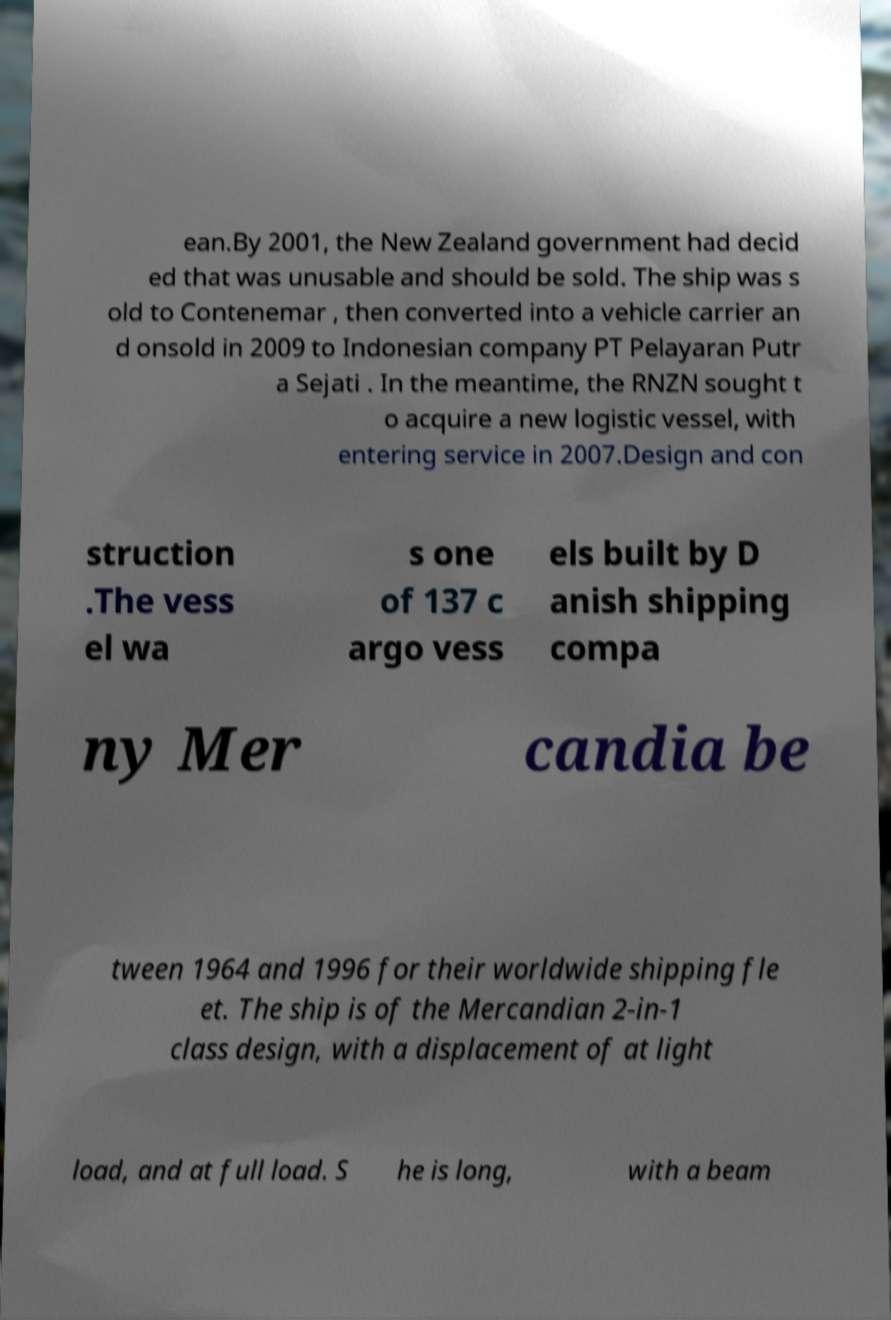Please identify and transcribe the text found in this image. ean.By 2001, the New Zealand government had decid ed that was unusable and should be sold. The ship was s old to Contenemar , then converted into a vehicle carrier an d onsold in 2009 to Indonesian company PT Pelayaran Putr a Sejati . In the meantime, the RNZN sought t o acquire a new logistic vessel, with entering service in 2007.Design and con struction .The vess el wa s one of 137 c argo vess els built by D anish shipping compa ny Mer candia be tween 1964 and 1996 for their worldwide shipping fle et. The ship is of the Mercandian 2-in-1 class design, with a displacement of at light load, and at full load. S he is long, with a beam 